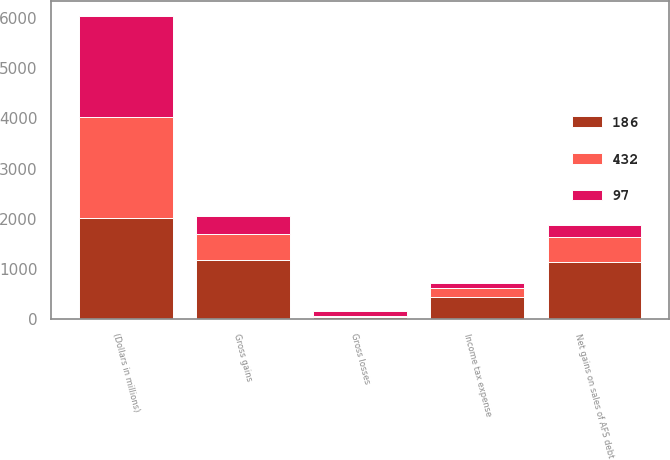Convert chart to OTSL. <chart><loc_0><loc_0><loc_500><loc_500><stacked_bar_chart><ecel><fcel>(Dollars in millions)<fcel>Gross gains<fcel>Gross losses<fcel>Net gains on sales of AFS debt<fcel>Income tax expense<nl><fcel>97<fcel>2017<fcel>352<fcel>97<fcel>255<fcel>97<nl><fcel>432<fcel>2016<fcel>520<fcel>30<fcel>490<fcel>186<nl><fcel>186<fcel>2015<fcel>1174<fcel>36<fcel>1138<fcel>432<nl></chart> 